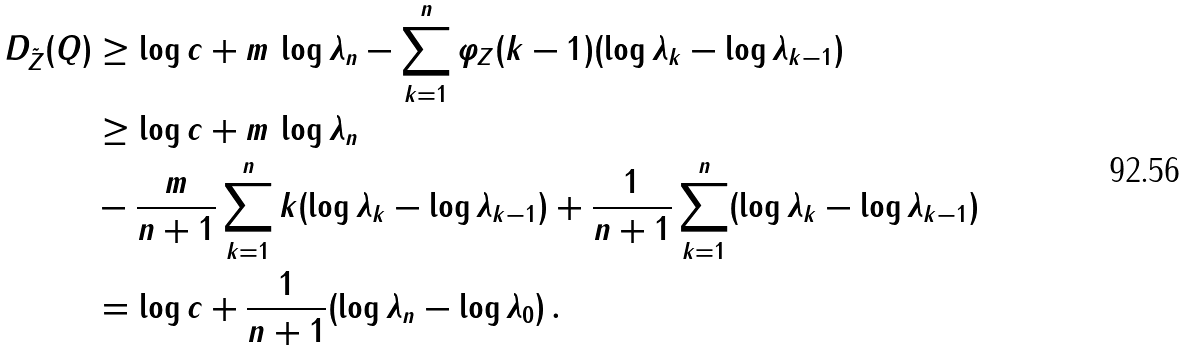<formula> <loc_0><loc_0><loc_500><loc_500>D _ { \tilde { Z } } ( Q ) & \geq \log c + m \, \log \lambda _ { n } - \sum _ { k = 1 } ^ { n } \varphi _ { Z } ( k - 1 ) ( \log \lambda _ { k } - \log \lambda _ { k - 1 } ) \\ & \geq \log c + m \, \log \lambda _ { n } \\ & - \frac { m } { n + 1 } \sum _ { k = 1 } ^ { n } k ( \log \lambda _ { k } - \log \lambda _ { k - 1 } ) + \frac { 1 } { n + 1 } \sum _ { k = 1 } ^ { n } ( \log \lambda _ { k } - \log \lambda _ { k - 1 } ) \\ & = \log c + \frac { 1 } { n + 1 } ( \log \lambda _ { n } - \log \lambda _ { 0 } ) \, .</formula> 